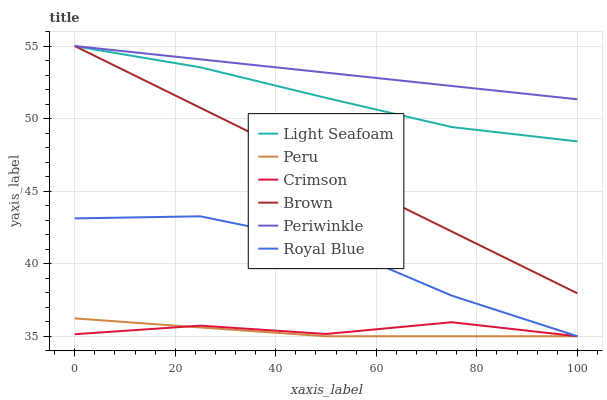Does Peru have the minimum area under the curve?
Answer yes or no. Yes. Does Periwinkle have the maximum area under the curve?
Answer yes or no. Yes. Does Royal Blue have the minimum area under the curve?
Answer yes or no. No. Does Royal Blue have the maximum area under the curve?
Answer yes or no. No. Is Brown the smoothest?
Answer yes or no. Yes. Is Royal Blue the roughest?
Answer yes or no. Yes. Is Periwinkle the smoothest?
Answer yes or no. No. Is Periwinkle the roughest?
Answer yes or no. No. Does Periwinkle have the lowest value?
Answer yes or no. No. Does Periwinkle have the highest value?
Answer yes or no. Yes. Does Royal Blue have the highest value?
Answer yes or no. No. Is Crimson less than Periwinkle?
Answer yes or no. Yes. Is Light Seafoam greater than Royal Blue?
Answer yes or no. Yes. Does Crimson intersect Periwinkle?
Answer yes or no. No. 